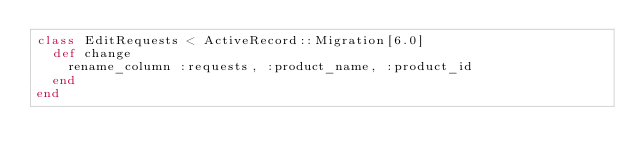<code> <loc_0><loc_0><loc_500><loc_500><_Ruby_>class EditRequests < ActiveRecord::Migration[6.0]
  def change
    rename_column :requests, :product_name, :product_id
  end
end
</code> 